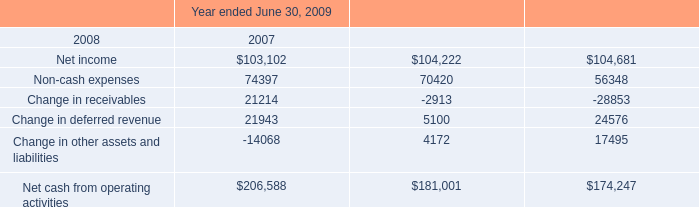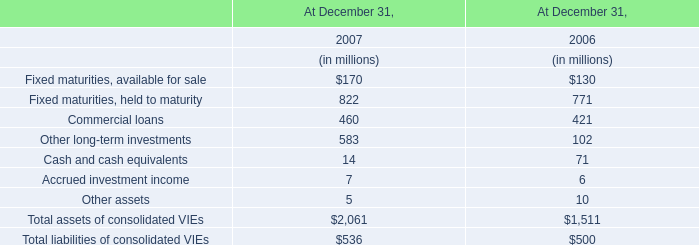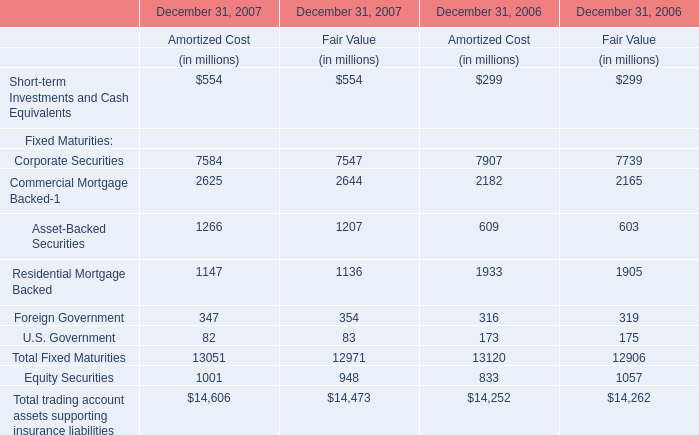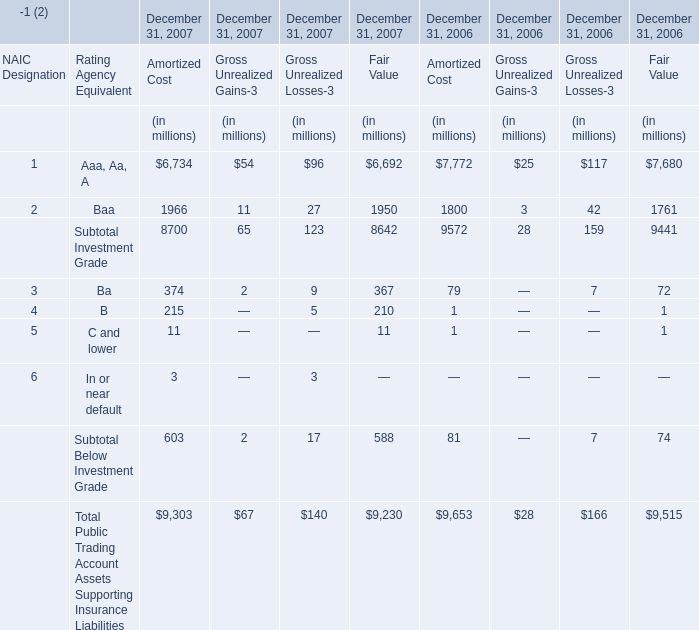What is the growing rate of Residential Mortgage Backed in the year with the most Asset-Backed Securities for fair value? (in %) 
Computations: ((1136 - 1905) / 1905)
Answer: -0.40367. 